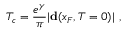Convert formula to latex. <formula><loc_0><loc_0><loc_500><loc_500>T _ { c } = \frac { e ^ { \gamma } } { \pi } | { d } ( x _ { F } , T = 0 ) | \ ,</formula> 